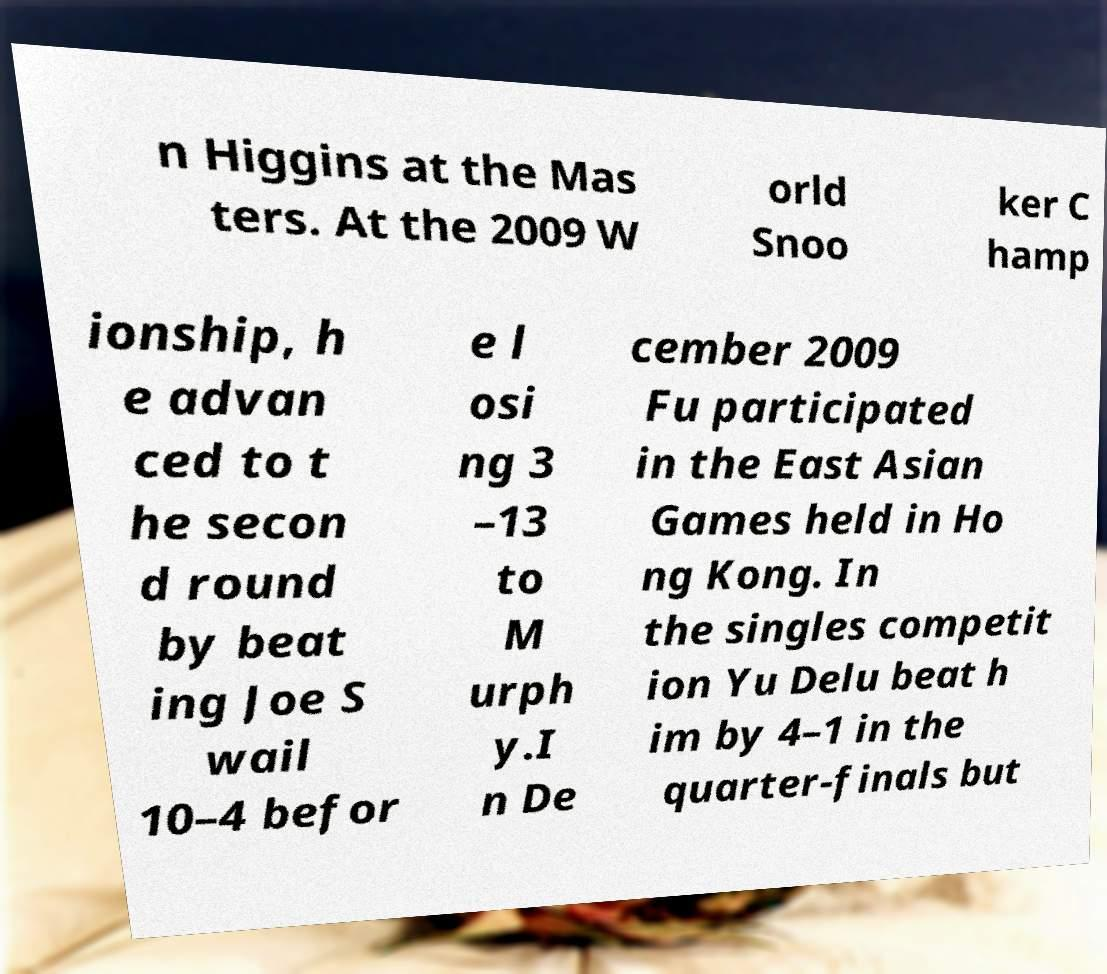Please identify and transcribe the text found in this image. n Higgins at the Mas ters. At the 2009 W orld Snoo ker C hamp ionship, h e advan ced to t he secon d round by beat ing Joe S wail 10–4 befor e l osi ng 3 –13 to M urph y.I n De cember 2009 Fu participated in the East Asian Games held in Ho ng Kong. In the singles competit ion Yu Delu beat h im by 4–1 in the quarter-finals but 